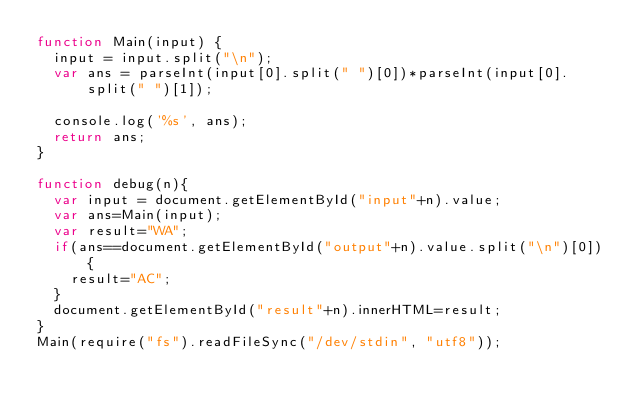Convert code to text. <code><loc_0><loc_0><loc_500><loc_500><_JavaScript_>function Main(input) {
  input = input.split("\n");
  var ans = parseInt(input[0].split(" ")[0])*parseInt(input[0].split(" ")[1]);

  console.log('%s', ans);
  return ans;
}

function debug(n){
  var input = document.getElementById("input"+n).value;
  var ans=Main(input);
  var result="WA";
  if(ans==document.getElementById("output"+n).value.split("\n")[0]){
    result="AC";
  }
  document.getElementById("result"+n).innerHTML=result;
}
Main(require("fs").readFileSync("/dev/stdin", "utf8"));</code> 